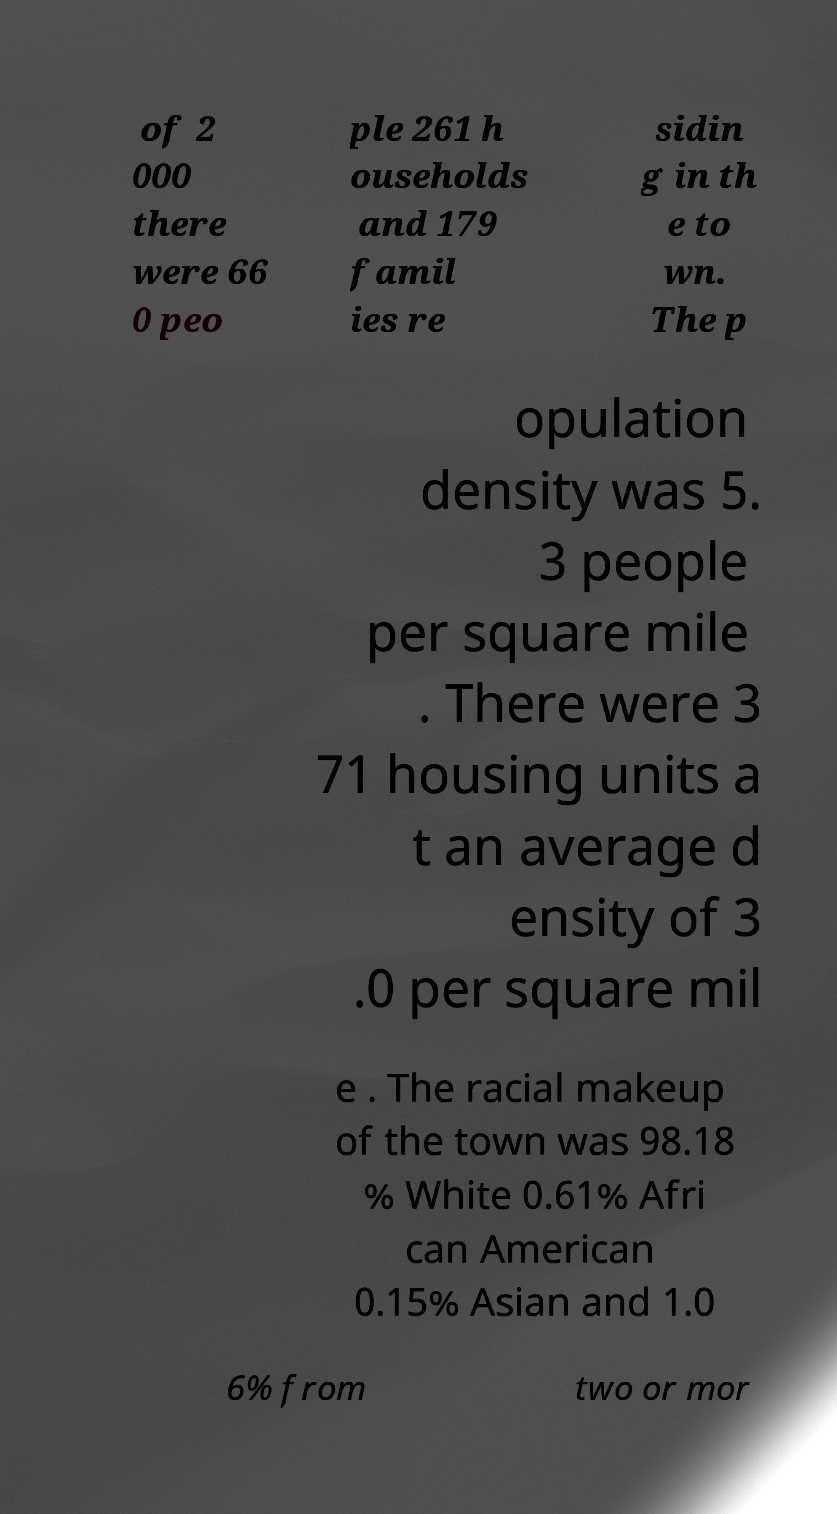Could you assist in decoding the text presented in this image and type it out clearly? of 2 000 there were 66 0 peo ple 261 h ouseholds and 179 famil ies re sidin g in th e to wn. The p opulation density was 5. 3 people per square mile . There were 3 71 housing units a t an average d ensity of 3 .0 per square mil e . The racial makeup of the town was 98.18 % White 0.61% Afri can American 0.15% Asian and 1.0 6% from two or mor 